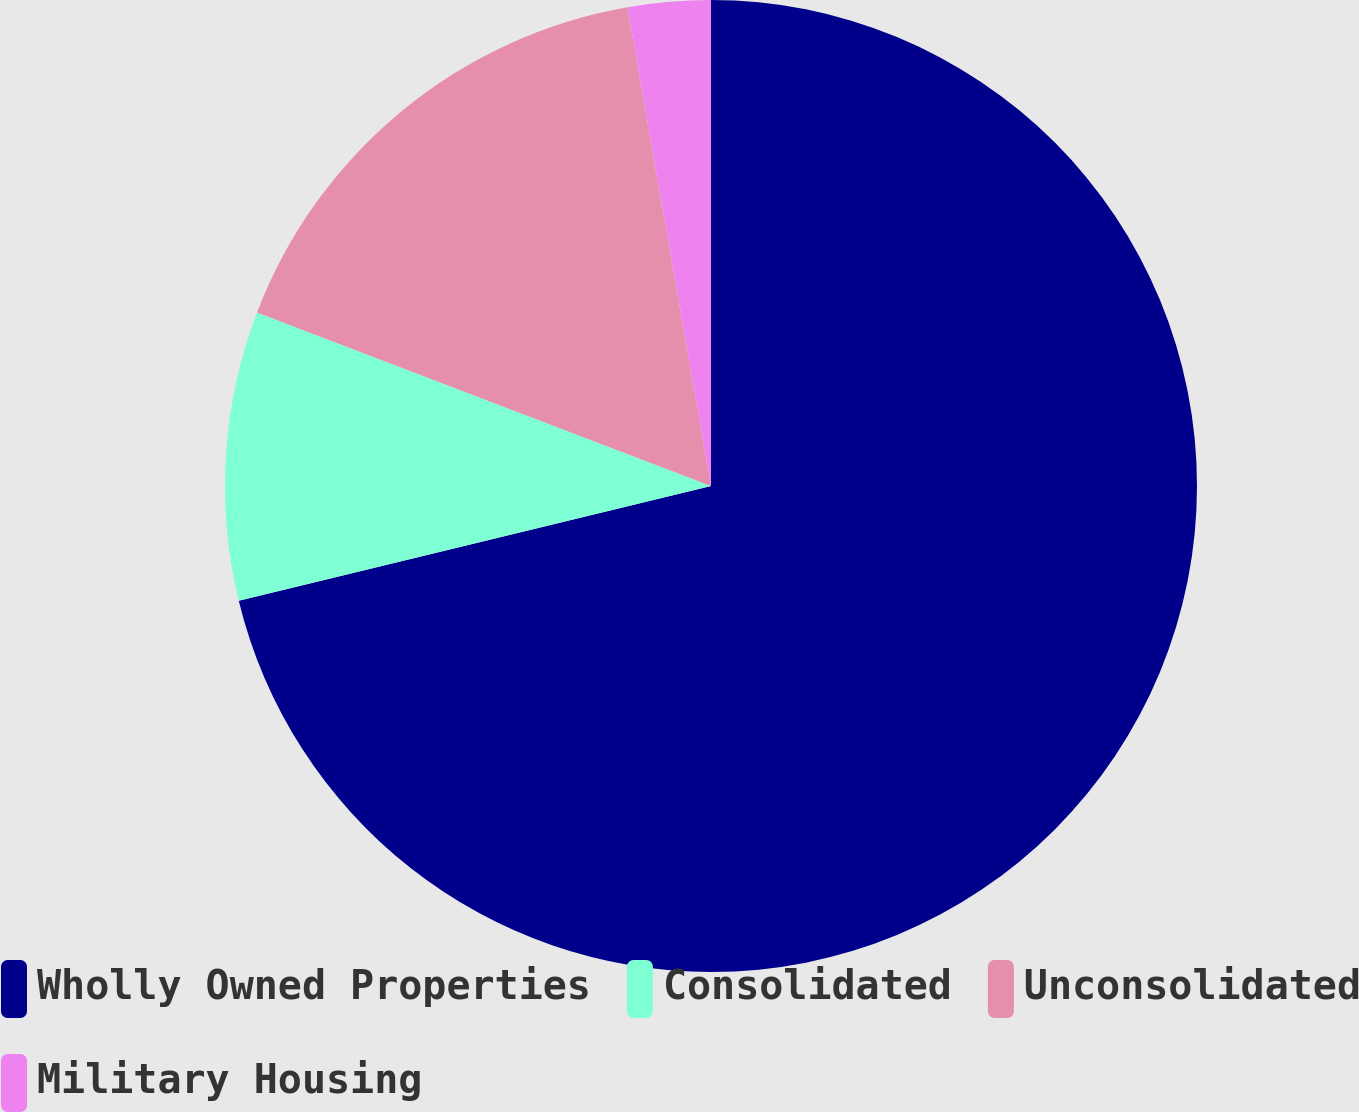<chart> <loc_0><loc_0><loc_500><loc_500><pie_chart><fcel>Wholly Owned Properties<fcel>Consolidated<fcel>Unconsolidated<fcel>Military Housing<nl><fcel>71.2%<fcel>9.6%<fcel>16.44%<fcel>2.75%<nl></chart> 